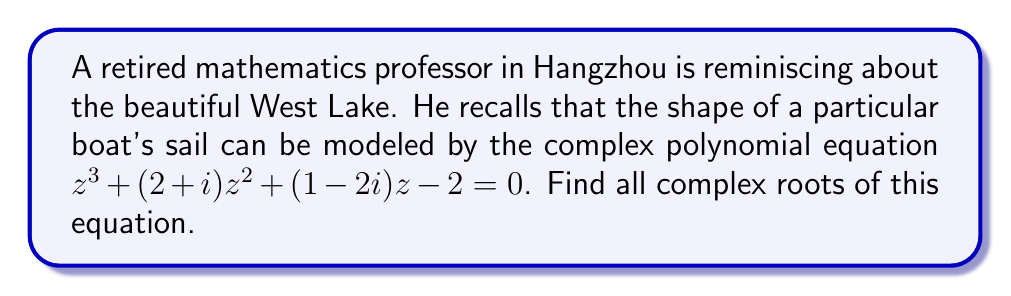Can you answer this question? To solve this polynomial equation with complex coefficients, we'll use the following steps:

1) First, we can try to factor out any real roots. Let's check if -2, -1, 0, 1, or 2 are roots:

   For z = -2: $(-2)^3 + (2+i)(-2)^2 + (1-2i)(-2) - 2 = -8 + 4(2+i) - 2(1-2i) - 2 = -8 + 8 + 4i - 2 + 4i - 2 = -4 + 8i \neq 0$

   Similarly, we can check that -1, 0, 1, and 2 are not roots.

2) Since there are no obvious real roots, we need to use the cubic formula or a numerical method. Let's use the cubic formula.

3) The general cubic equation is $ax^3 + bx^2 + cx + d = 0$. In our case:
   $a = 1$, $b = 2+i$, $c = 1-2i$, $d = -2$

4) Define $p$ and $q$:
   $p = \frac{3ac-b^2}{3a^2} = \frac{3(1)(1-2i)-(2+i)^2}{3(1)^2} = \frac{3-6i-4-4i-1}{3} = -\frac{5+10i}{3}$
   
   $q = \frac{2b^3-9abc+27a^2d}{27a^3} = \frac{2(2+i)^3-9(1)(2+i)(1-2i)+27(1)^2(-2)}{27(1)^3}$
      $= \frac{2(8+12i-1)-9(2+i-4i-2)-54}{27} = \frac{14+24i-18+27i+18-54}{27} = -\frac{40-51i}{27}$

5) Calculate the discriminant $\Delta = (\frac{q}{2})^2 + (\frac{p}{3})^3$:
   $\Delta = (\frac{-40+51i}{54})^2 + (\frac{-5-10i}{9})^3$

6) The roots are given by:
   $z_k = -\frac{b}{3a} + \sqrt[3]{-\frac{q}{2} + \sqrt{\Delta}} + \sqrt[3]{-\frac{q}{2} - \sqrt{\Delta}}$

   Where $k = 0, 1, 2$ and $\sqrt[3]{1} = 1, -\frac{1}{2} + i\frac{\sqrt{3}}{2}, -\frac{1}{2} - i\frac{\sqrt{3}}{2}$

7) Calculating these values numerically (as the exact form is very complex):
   $z_1 \approx -0.9397 + 0.7164i$
   $z_2 \approx 0.4699 - 1.8582i$
   $z_3 \approx -1.5302 + 0.1418i$
Answer: $z_1 \approx -0.9397 + 0.7164i$, $z_2 \approx 0.4699 - 1.8582i$, $z_3 \approx -1.5302 + 0.1418i$ 